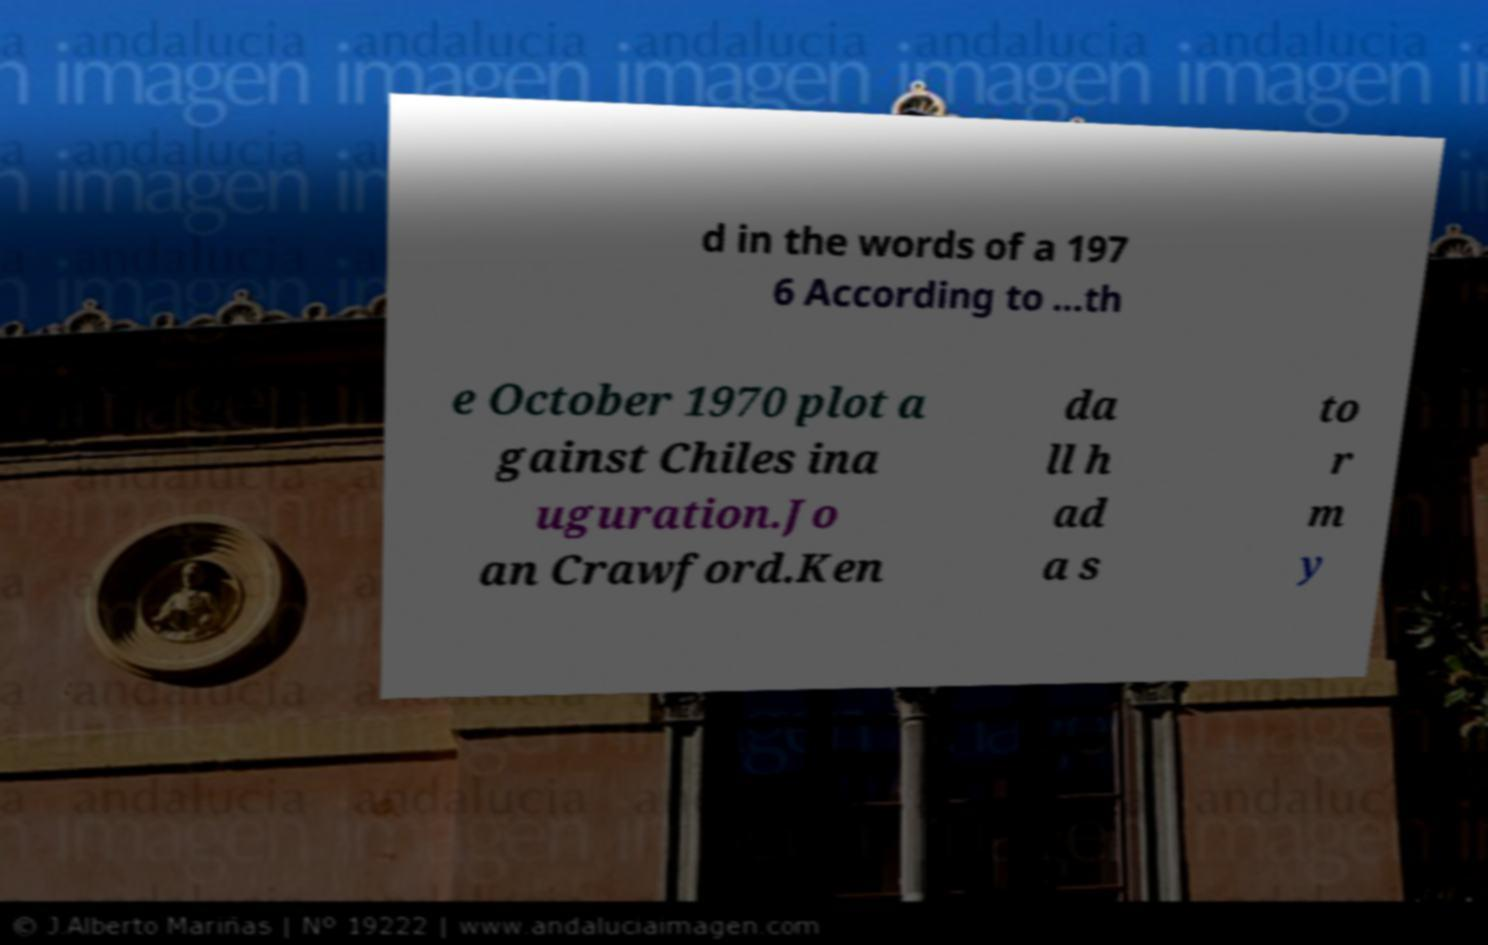I need the written content from this picture converted into text. Can you do that? d in the words of a 197 6 According to ...th e October 1970 plot a gainst Chiles ina uguration.Jo an Crawford.Ken da ll h ad a s to r m y 